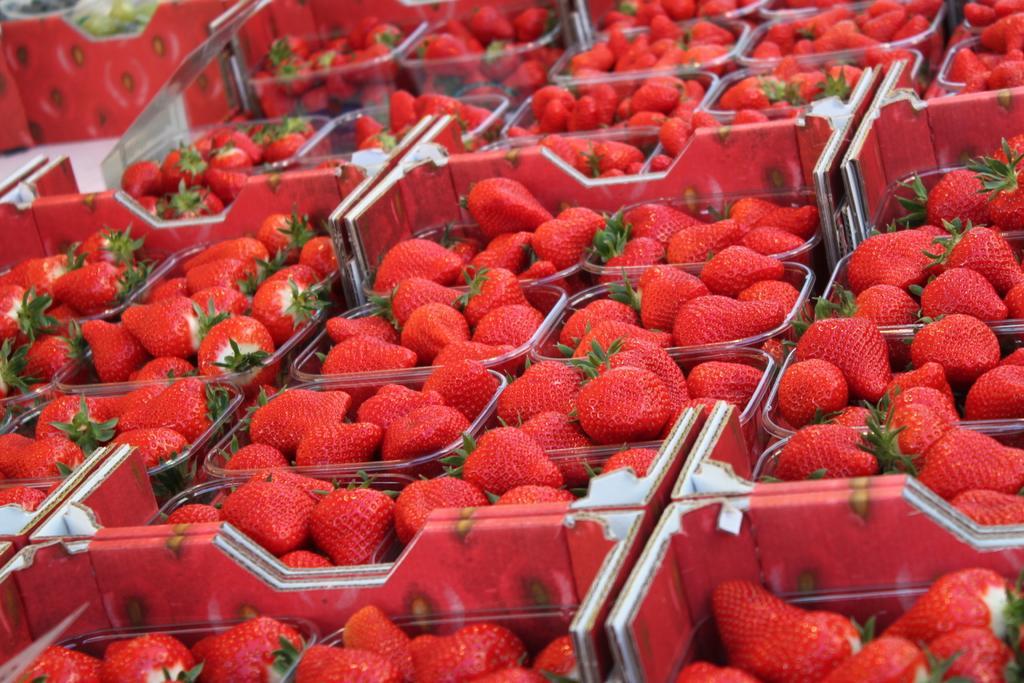In one or two sentences, can you explain what this image depicts? In this picture I can see many strawberries which are kept in the different plastic boxes. In the top left corner I can see the fruits which are kept on the cotton box. 